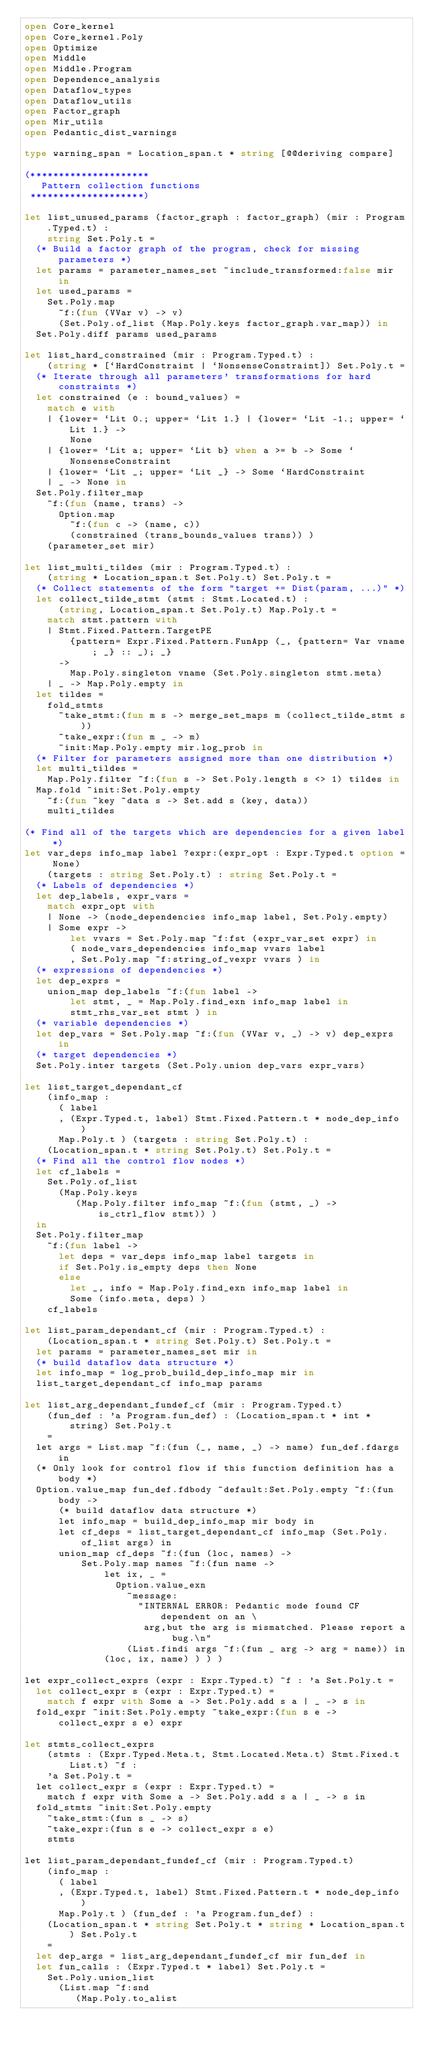<code> <loc_0><loc_0><loc_500><loc_500><_OCaml_>open Core_kernel
open Core_kernel.Poly
open Optimize
open Middle
open Middle.Program
open Dependence_analysis
open Dataflow_types
open Dataflow_utils
open Factor_graph
open Mir_utils
open Pedantic_dist_warnings

type warning_span = Location_span.t * string [@@deriving compare]

(*********************
   Pattern collection functions
 ********************)

let list_unused_params (factor_graph : factor_graph) (mir : Program.Typed.t) :
    string Set.Poly.t =
  (* Build a factor graph of the program, check for missing parameters *)
  let params = parameter_names_set ~include_transformed:false mir in
  let used_params =
    Set.Poly.map
      ~f:(fun (VVar v) -> v)
      (Set.Poly.of_list (Map.Poly.keys factor_graph.var_map)) in
  Set.Poly.diff params used_params

let list_hard_constrained (mir : Program.Typed.t) :
    (string * [`HardConstraint | `NonsenseConstraint]) Set.Poly.t =
  (* Iterate through all parameters' transformations for hard constraints *)
  let constrained (e : bound_values) =
    match e with
    | {lower= `Lit 0.; upper= `Lit 1.} | {lower= `Lit -1.; upper= `Lit 1.} ->
        None
    | {lower= `Lit a; upper= `Lit b} when a >= b -> Some `NonsenseConstraint
    | {lower= `Lit _; upper= `Lit _} -> Some `HardConstraint
    | _ -> None in
  Set.Poly.filter_map
    ~f:(fun (name, trans) ->
      Option.map
        ~f:(fun c -> (name, c))
        (constrained (trans_bounds_values trans)) )
    (parameter_set mir)

let list_multi_tildes (mir : Program.Typed.t) :
    (string * Location_span.t Set.Poly.t) Set.Poly.t =
  (* Collect statements of the form "target += Dist(param, ...)" *)
  let collect_tilde_stmt (stmt : Stmt.Located.t) :
      (string, Location_span.t Set.Poly.t) Map.Poly.t =
    match stmt.pattern with
    | Stmt.Fixed.Pattern.TargetPE
        {pattern= Expr.Fixed.Pattern.FunApp (_, {pattern= Var vname; _} :: _); _}
      ->
        Map.Poly.singleton vname (Set.Poly.singleton stmt.meta)
    | _ -> Map.Poly.empty in
  let tildes =
    fold_stmts
      ~take_stmt:(fun m s -> merge_set_maps m (collect_tilde_stmt s))
      ~take_expr:(fun m _ -> m)
      ~init:Map.Poly.empty mir.log_prob in
  (* Filter for parameters assigned more than one distribution *)
  let multi_tildes =
    Map.Poly.filter ~f:(fun s -> Set.Poly.length s <> 1) tildes in
  Map.fold ~init:Set.Poly.empty
    ~f:(fun ~key ~data s -> Set.add s (key, data))
    multi_tildes

(* Find all of the targets which are dependencies for a given label *)
let var_deps info_map label ?expr:(expr_opt : Expr.Typed.t option = None)
    (targets : string Set.Poly.t) : string Set.Poly.t =
  (* Labels of dependencies *)
  let dep_labels, expr_vars =
    match expr_opt with
    | None -> (node_dependencies info_map label, Set.Poly.empty)
    | Some expr ->
        let vvars = Set.Poly.map ~f:fst (expr_var_set expr) in
        ( node_vars_dependencies info_map vvars label
        , Set.Poly.map ~f:string_of_vexpr vvars ) in
  (* expressions of dependencies *)
  let dep_exprs =
    union_map dep_labels ~f:(fun label ->
        let stmt, _ = Map.Poly.find_exn info_map label in
        stmt_rhs_var_set stmt ) in
  (* variable dependencies *)
  let dep_vars = Set.Poly.map ~f:(fun (VVar v, _) -> v) dep_exprs in
  (* target dependencies *)
  Set.Poly.inter targets (Set.Poly.union dep_vars expr_vars)

let list_target_dependant_cf
    (info_map :
      ( label
      , (Expr.Typed.t, label) Stmt.Fixed.Pattern.t * node_dep_info )
      Map.Poly.t ) (targets : string Set.Poly.t) :
    (Location_span.t * string Set.Poly.t) Set.Poly.t =
  (* Find all the control flow nodes *)
  let cf_labels =
    Set.Poly.of_list
      (Map.Poly.keys
         (Map.Poly.filter info_map ~f:(fun (stmt, _) -> is_ctrl_flow stmt)) )
  in
  Set.Poly.filter_map
    ~f:(fun label ->
      let deps = var_deps info_map label targets in
      if Set.Poly.is_empty deps then None
      else
        let _, info = Map.Poly.find_exn info_map label in
        Some (info.meta, deps) )
    cf_labels

let list_param_dependant_cf (mir : Program.Typed.t) :
    (Location_span.t * string Set.Poly.t) Set.Poly.t =
  let params = parameter_names_set mir in
  (* build dataflow data structure *)
  let info_map = log_prob_build_dep_info_map mir in
  list_target_dependant_cf info_map params

let list_arg_dependant_fundef_cf (mir : Program.Typed.t)
    (fun_def : 'a Program.fun_def) : (Location_span.t * int * string) Set.Poly.t
    =
  let args = List.map ~f:(fun (_, name, _) -> name) fun_def.fdargs in
  (* Only look for control flow if this function definition has a body *)
  Option.value_map fun_def.fdbody ~default:Set.Poly.empty ~f:(fun body ->
      (* build dataflow data structure *)
      let info_map = build_dep_info_map mir body in
      let cf_deps = list_target_dependant_cf info_map (Set.Poly.of_list args) in
      union_map cf_deps ~f:(fun (loc, names) ->
          Set.Poly.map names ~f:(fun name ->
              let ix, _ =
                Option.value_exn
                  ~message:
                    "INTERNAL ERROR: Pedantic mode found CF dependent on an \
                     arg,but the arg is mismatched. Please report a bug.\n"
                  (List.findi args ~f:(fun _ arg -> arg = name)) in
              (loc, ix, name) ) ) )

let expr_collect_exprs (expr : Expr.Typed.t) ~f : 'a Set.Poly.t =
  let collect_expr s (expr : Expr.Typed.t) =
    match f expr with Some a -> Set.Poly.add s a | _ -> s in
  fold_expr ~init:Set.Poly.empty ~take_expr:(fun s e -> collect_expr s e) expr

let stmts_collect_exprs
    (stmts : (Expr.Typed.Meta.t, Stmt.Located.Meta.t) Stmt.Fixed.t List.t) ~f :
    'a Set.Poly.t =
  let collect_expr s (expr : Expr.Typed.t) =
    match f expr with Some a -> Set.Poly.add s a | _ -> s in
  fold_stmts ~init:Set.Poly.empty
    ~take_stmt:(fun s _ -> s)
    ~take_expr:(fun s e -> collect_expr s e)
    stmts

let list_param_dependant_fundef_cf (mir : Program.Typed.t)
    (info_map :
      ( label
      , (Expr.Typed.t, label) Stmt.Fixed.Pattern.t * node_dep_info )
      Map.Poly.t ) (fun_def : 'a Program.fun_def) :
    (Location_span.t * string Set.Poly.t * string * Location_span.t) Set.Poly.t
    =
  let dep_args = list_arg_dependant_fundef_cf mir fun_def in
  let fun_calls : (Expr.Typed.t * label) Set.Poly.t =
    Set.Poly.union_list
      (List.map ~f:snd
         (Map.Poly.to_alist</code> 